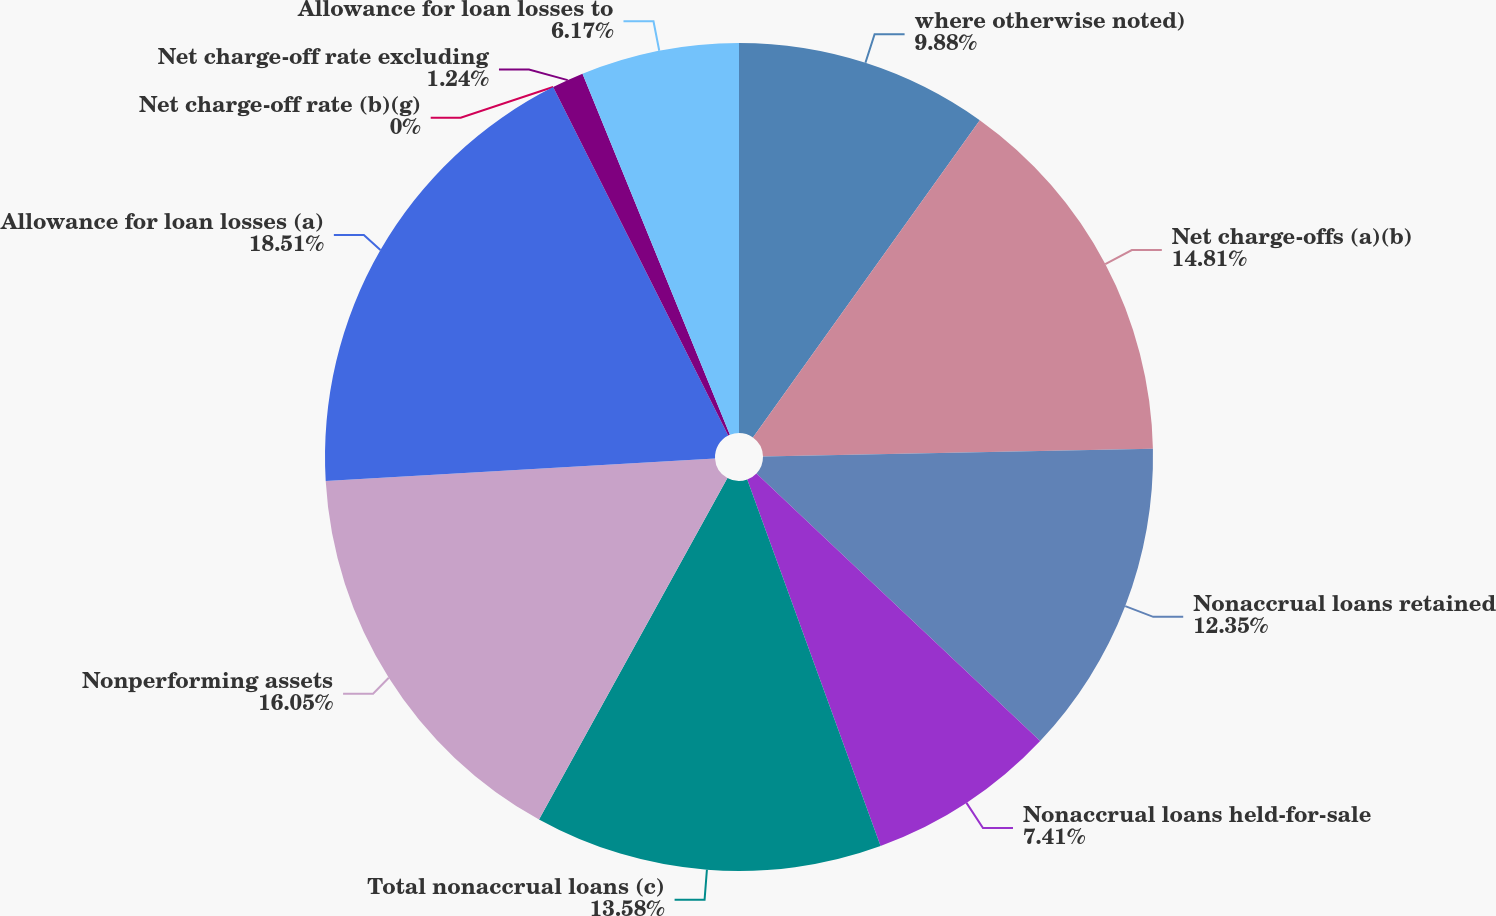Convert chart to OTSL. <chart><loc_0><loc_0><loc_500><loc_500><pie_chart><fcel>where otherwise noted)<fcel>Net charge-offs (a)(b)<fcel>Nonaccrual loans retained<fcel>Nonaccrual loans held-for-sale<fcel>Total nonaccrual loans (c)<fcel>Nonperforming assets<fcel>Allowance for loan losses (a)<fcel>Net charge-off rate (b)(g)<fcel>Net charge-off rate excluding<fcel>Allowance for loan losses to<nl><fcel>9.88%<fcel>14.81%<fcel>12.35%<fcel>7.41%<fcel>13.58%<fcel>16.05%<fcel>18.52%<fcel>0.0%<fcel>1.24%<fcel>6.17%<nl></chart> 